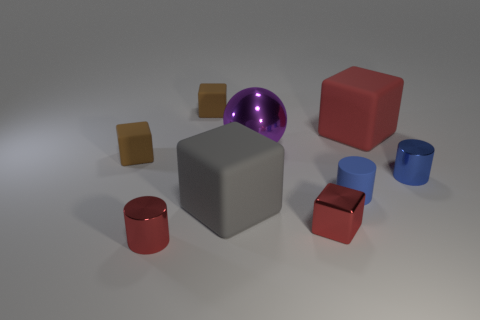Subtract all matte blocks. How many blocks are left? 1 Subtract all gray blocks. How many blocks are left? 4 Subtract all blue blocks. Subtract all yellow spheres. How many blocks are left? 5 Subtract all blocks. How many objects are left? 4 Subtract all large green matte cylinders. Subtract all purple metal spheres. How many objects are left? 8 Add 8 blue cylinders. How many blue cylinders are left? 10 Add 8 tiny metal blocks. How many tiny metal blocks exist? 9 Subtract 0 cyan cylinders. How many objects are left? 9 